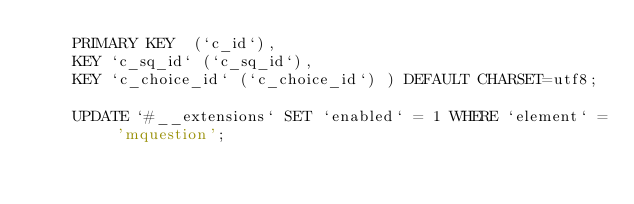<code> <loc_0><loc_0><loc_500><loc_500><_SQL_>		PRIMARY KEY  (`c_id`),
		KEY `c_sq_id` (`c_sq_id`),
		KEY `c_choice_id` (`c_choice_id`) ) DEFAULT CHARSET=utf8;

		UPDATE `#__extensions` SET `enabled` = 1 WHERE `element` = 'mquestion';
</code> 